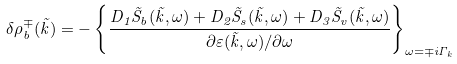<formula> <loc_0><loc_0><loc_500><loc_500>\delta \rho _ { b } ^ { \mp } ( \vec { k } ) = - \left \{ \frac { D _ { 1 } \tilde { S } _ { b } ( \vec { k } , \omega ) + D _ { 2 } \tilde { S } _ { s } ( \vec { k } , \omega ) + D _ { 3 } \tilde { S } _ { v } ( \vec { k } , \omega ) } { \partial \varepsilon ( \vec { k } , \omega ) / \partial \omega } \right \} _ { \omega = \mp i \Gamma _ { k } }</formula> 